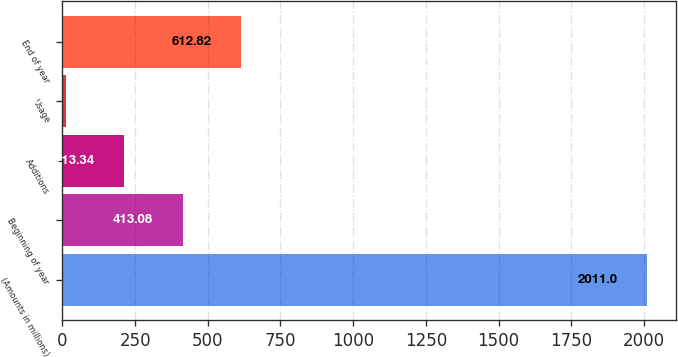Convert chart. <chart><loc_0><loc_0><loc_500><loc_500><bar_chart><fcel>(Amounts in millions)<fcel>Beginning of year<fcel>Additions<fcel>Usage<fcel>End of year<nl><fcel>2011<fcel>413.08<fcel>213.34<fcel>13.6<fcel>612.82<nl></chart> 